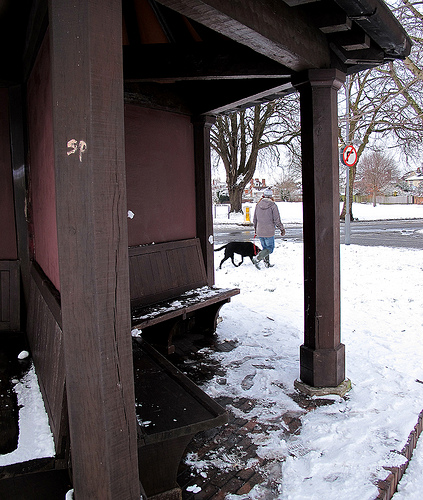Read and extract the text from this image. SP 